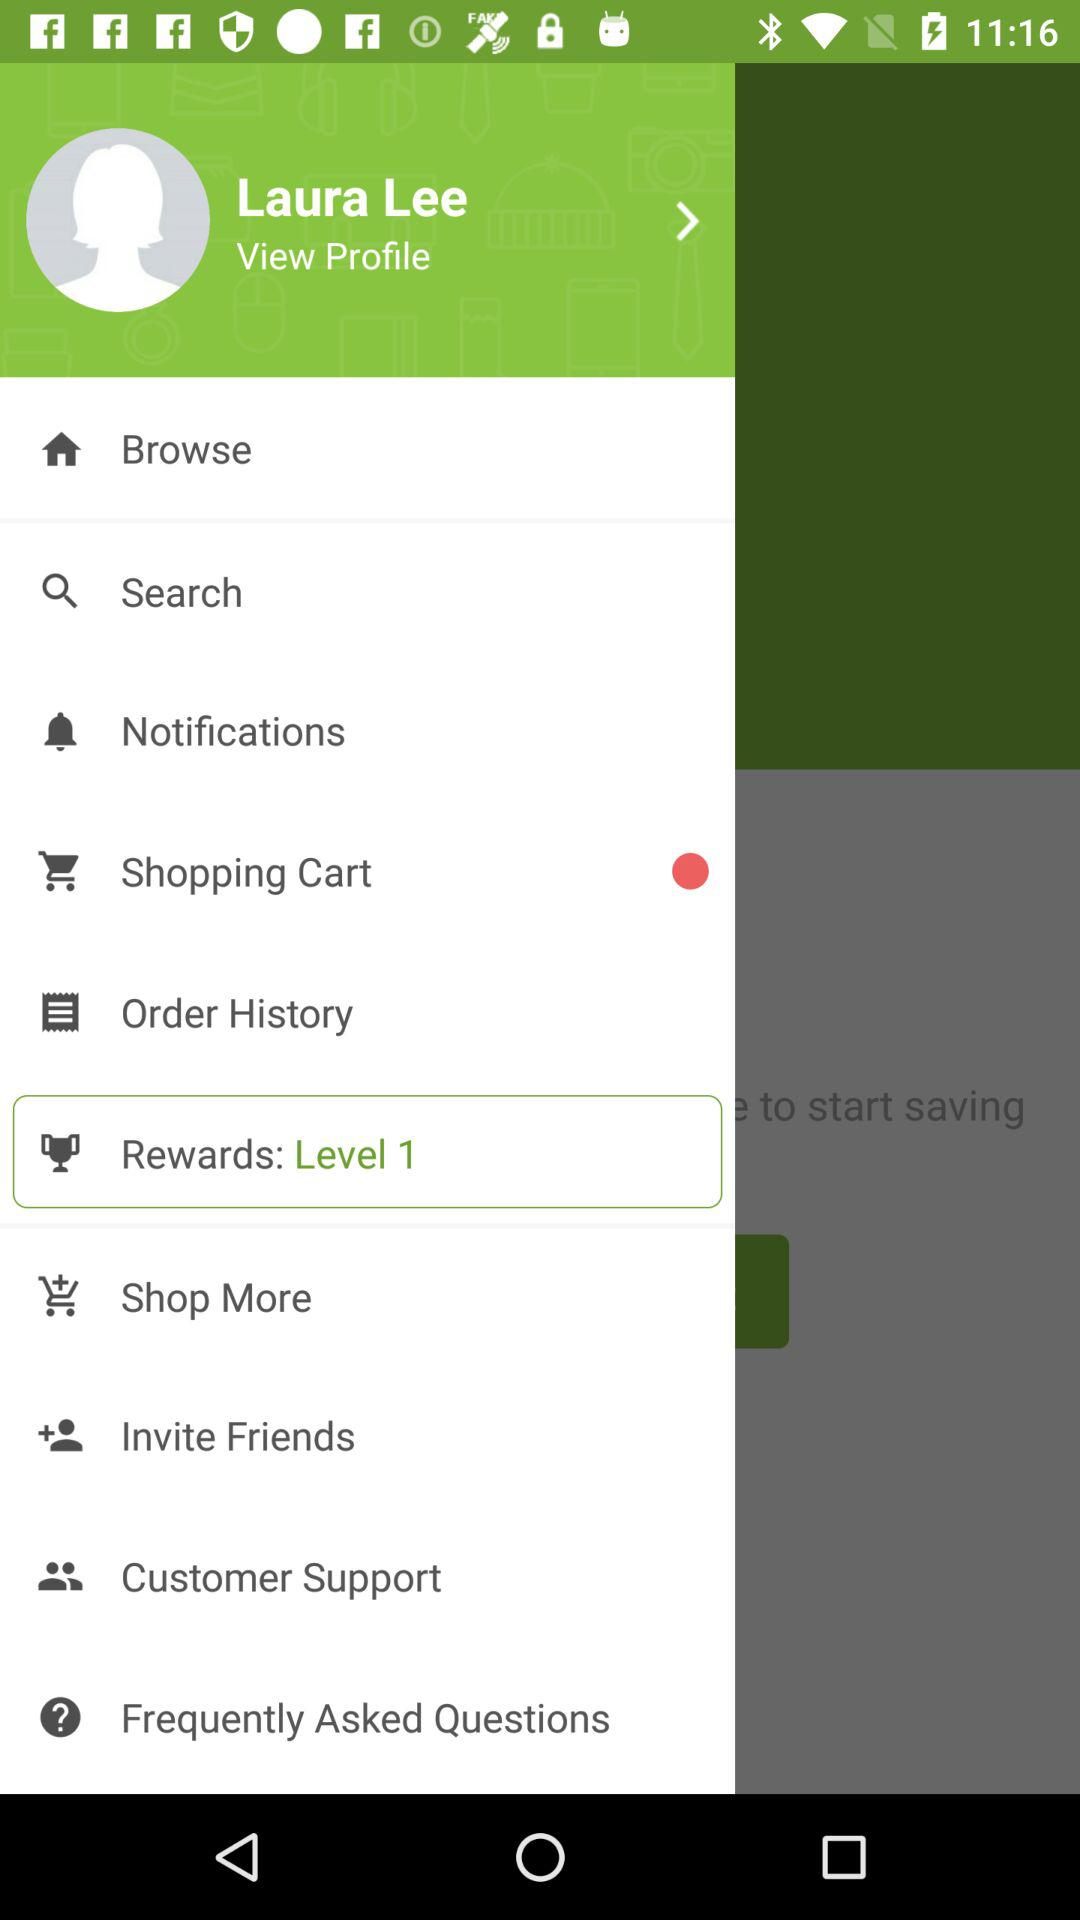What is the level number? The level number is 1. 